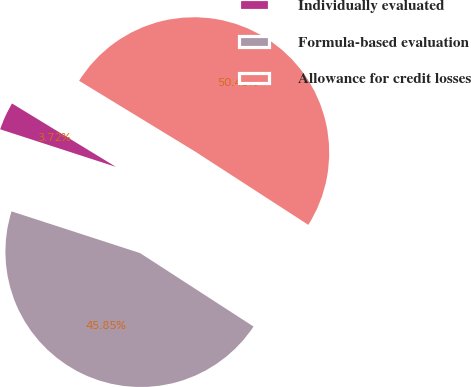Convert chart. <chart><loc_0><loc_0><loc_500><loc_500><pie_chart><fcel>Individually evaluated<fcel>Formula-based evaluation<fcel>Allowance for credit losses<nl><fcel>3.72%<fcel>45.85%<fcel>50.43%<nl></chart> 